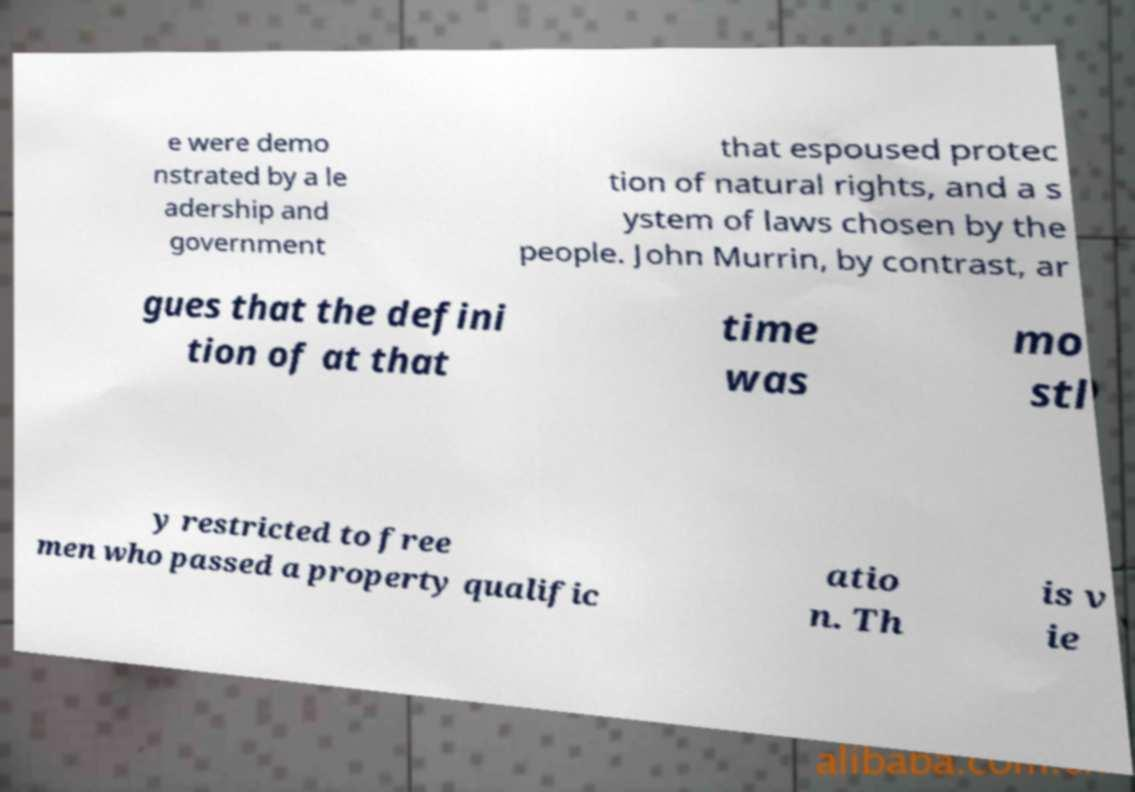Please read and relay the text visible in this image. What does it say? e were demo nstrated by a le adership and government that espoused protec tion of natural rights, and a s ystem of laws chosen by the people. John Murrin, by contrast, ar gues that the defini tion of at that time was mo stl y restricted to free men who passed a property qualific atio n. Th is v ie 